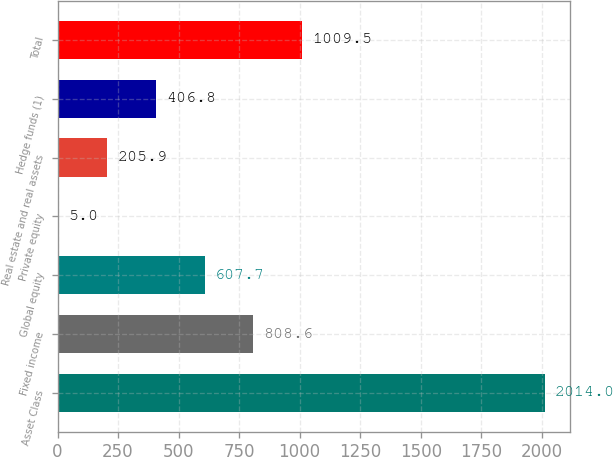<chart> <loc_0><loc_0><loc_500><loc_500><bar_chart><fcel>Asset Class<fcel>Fixed income<fcel>Global equity<fcel>Private equity<fcel>Real estate and real assets<fcel>Hedge funds (1)<fcel>Total<nl><fcel>2014<fcel>808.6<fcel>607.7<fcel>5<fcel>205.9<fcel>406.8<fcel>1009.5<nl></chart> 